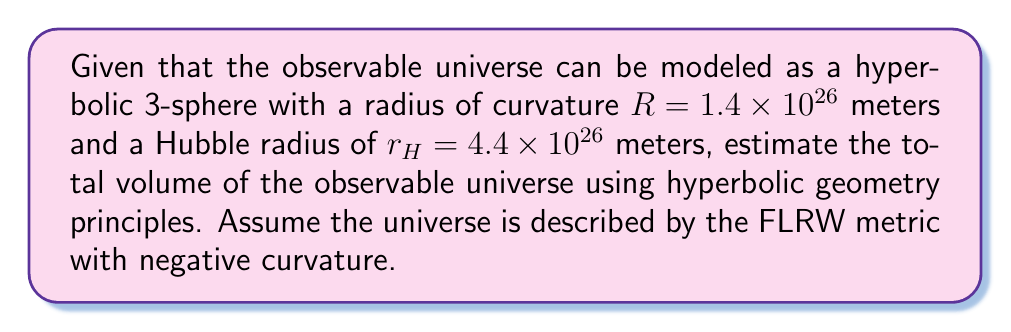Solve this math problem. To estimate the volume of the observable universe using hyperbolic geometry, we'll follow these steps:

1) In hyperbolic geometry, the volume of a 3-sphere with radius $r$ is given by:

   $$V = 2\pi R^3 (\sinh(r/R) - r/R)$$

   where $R$ is the radius of curvature.

2) We need to use the Hubble radius $r_H$ as our $r$ value, as this represents the observable universe's radius.

3) Let's substitute the given values:
   $R = 1.4 \times 10^{26}$ meters
   $r_H = 4.4 \times 10^{26}$ meters

4) Calculate $r_H/R$:
   $$r_H/R = (4.4 \times 10^{26}) / (1.4 \times 10^{26}) = 3.14285714$$

5) Now, let's calculate $\sinh(r_H/R)$:
   $$\sinh(3.14285714) \approx 11.5443$$

6) Substituting these values into our volume formula:

   $$V = 2\pi (1.4 \times 10^{26})^3 (11.5443 - 3.14285714)$$

7) Simplifying:
   $$V = 2\pi (2.744 \times 10^{78}) (8.40144286)$$
   $$V \approx 1.45 \times 10^{80}~\text{m}^3$$

8) Convert to cubic light-years for a more manageable number:
   1 light-year = 9.461 × 10^15 meters
   $(9.461 \times 10^{15})^3 = 8.47 \times 10^{47}~\text{m}^3/\text{ly}^3$

   $$V \approx (1.45 \times 10^{80}) / (8.47 \times 10^{47}) \approx 1.71 \times 10^{32}~\text{ly}^3$$
Answer: $1.71 \times 10^{32}~\text{cubic light-years}$ 